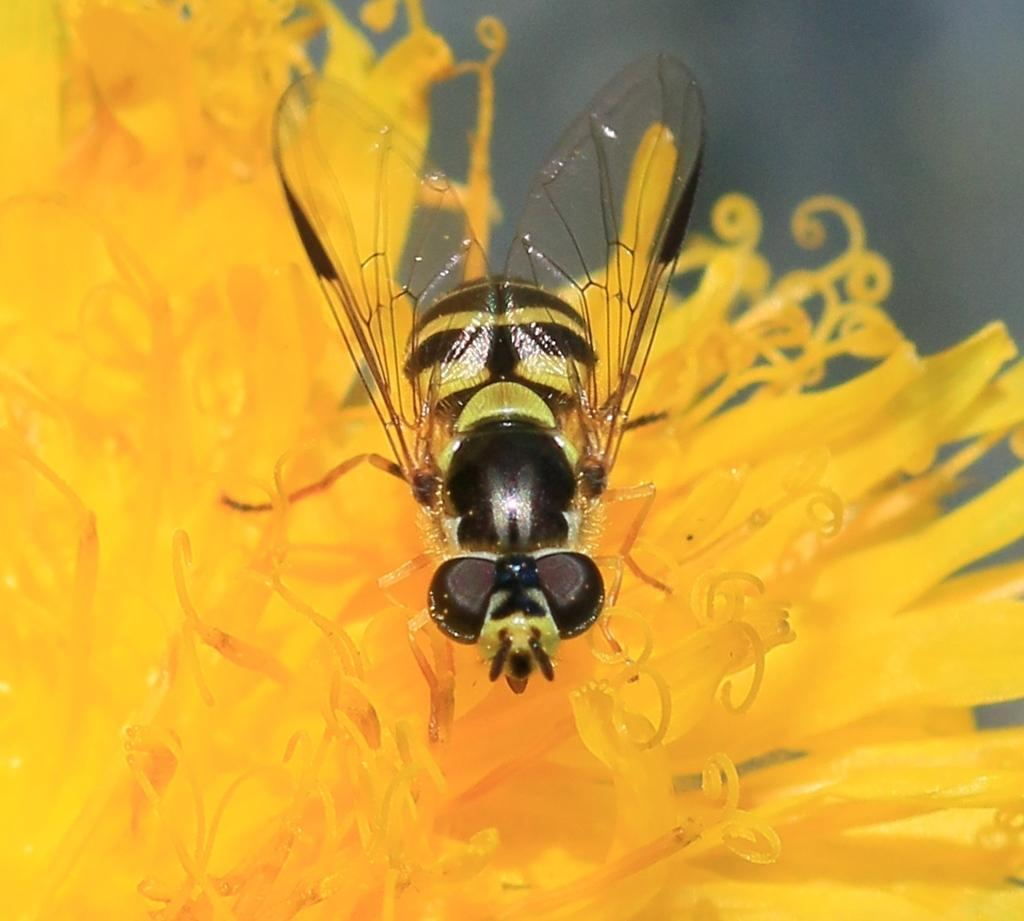What is: What type of insect is in the image? There is a honey bee in the image. What is the honey bee doing in the image? The honey bee is on a yellow flower. How many toes can be seen on the honey bee in the image? Honey bees do not have toes, as they are insects and have six legs instead. 